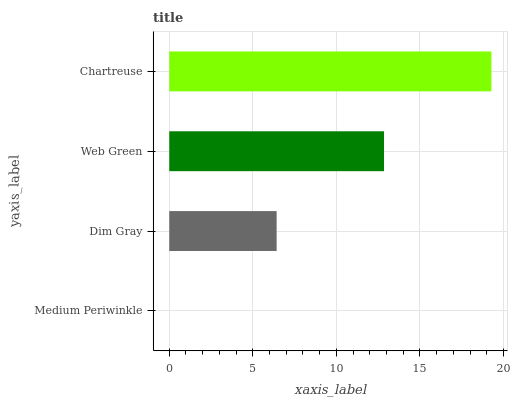Is Medium Periwinkle the minimum?
Answer yes or no. Yes. Is Chartreuse the maximum?
Answer yes or no. Yes. Is Dim Gray the minimum?
Answer yes or no. No. Is Dim Gray the maximum?
Answer yes or no. No. Is Dim Gray greater than Medium Periwinkle?
Answer yes or no. Yes. Is Medium Periwinkle less than Dim Gray?
Answer yes or no. Yes. Is Medium Periwinkle greater than Dim Gray?
Answer yes or no. No. Is Dim Gray less than Medium Periwinkle?
Answer yes or no. No. Is Web Green the high median?
Answer yes or no. Yes. Is Dim Gray the low median?
Answer yes or no. Yes. Is Medium Periwinkle the high median?
Answer yes or no. No. Is Medium Periwinkle the low median?
Answer yes or no. No. 